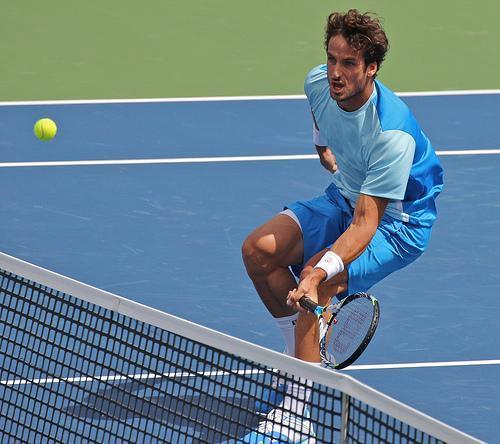How many people on the field?
Give a very brief answer. 1. 